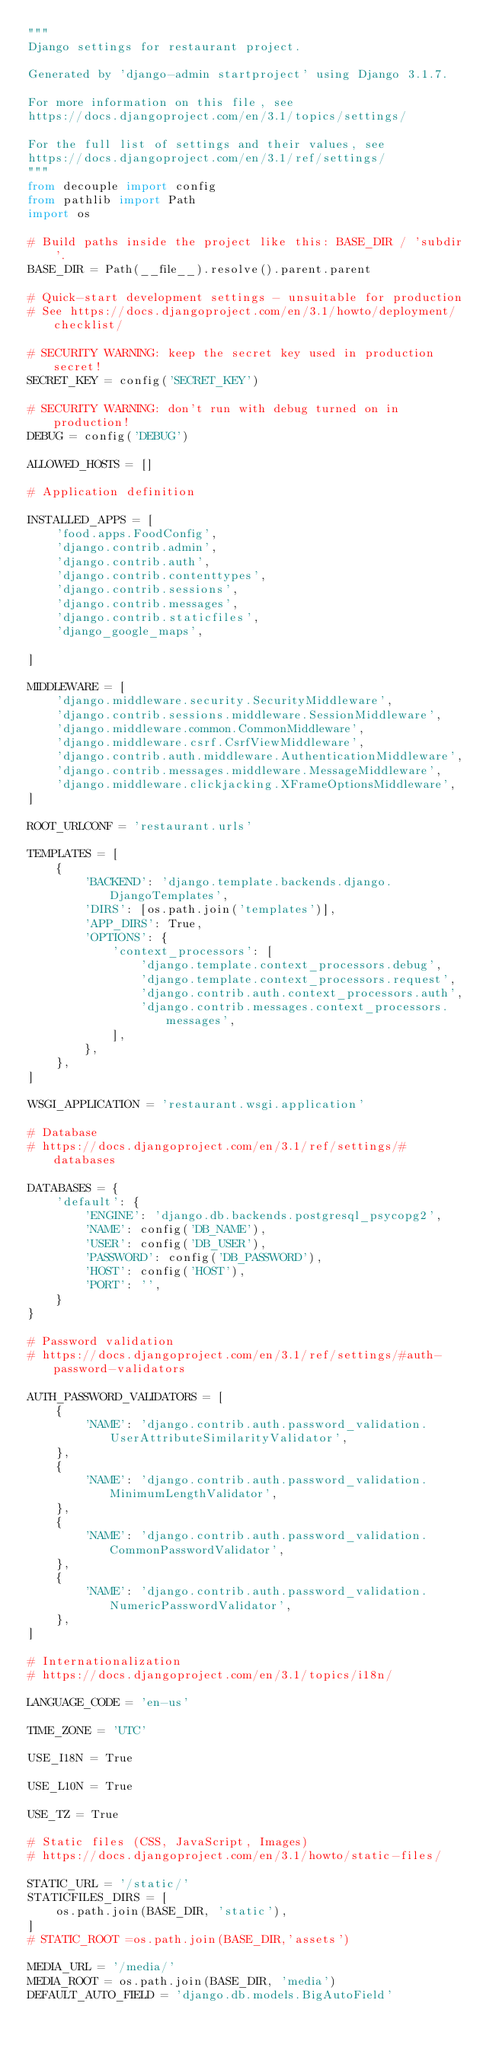Convert code to text. <code><loc_0><loc_0><loc_500><loc_500><_Python_>"""
Django settings for restaurant project.

Generated by 'django-admin startproject' using Django 3.1.7.

For more information on this file, see
https://docs.djangoproject.com/en/3.1/topics/settings/

For the full list of settings and their values, see
https://docs.djangoproject.com/en/3.1/ref/settings/
"""
from decouple import config
from pathlib import Path
import os

# Build paths inside the project like this: BASE_DIR / 'subdir'.
BASE_DIR = Path(__file__).resolve().parent.parent

# Quick-start development settings - unsuitable for production
# See https://docs.djangoproject.com/en/3.1/howto/deployment/checklist/

# SECURITY WARNING: keep the secret key used in production secret!
SECRET_KEY = config('SECRET_KEY')

# SECURITY WARNING: don't run with debug turned on in production!
DEBUG = config('DEBUG')

ALLOWED_HOSTS = []

# Application definition

INSTALLED_APPS = [
    'food.apps.FoodConfig',
    'django.contrib.admin',
    'django.contrib.auth',
    'django.contrib.contenttypes',
    'django.contrib.sessions',
    'django.contrib.messages',
    'django.contrib.staticfiles',
    'django_google_maps',

]

MIDDLEWARE = [
    'django.middleware.security.SecurityMiddleware',
    'django.contrib.sessions.middleware.SessionMiddleware',
    'django.middleware.common.CommonMiddleware',
    'django.middleware.csrf.CsrfViewMiddleware',
    'django.contrib.auth.middleware.AuthenticationMiddleware',
    'django.contrib.messages.middleware.MessageMiddleware',
    'django.middleware.clickjacking.XFrameOptionsMiddleware',
]

ROOT_URLCONF = 'restaurant.urls'

TEMPLATES = [
    {
        'BACKEND': 'django.template.backends.django.DjangoTemplates',
        'DIRS': [os.path.join('templates')],
        'APP_DIRS': True,
        'OPTIONS': {
            'context_processors': [
                'django.template.context_processors.debug',
                'django.template.context_processors.request',
                'django.contrib.auth.context_processors.auth',
                'django.contrib.messages.context_processors.messages',
            ],
        },
    },
]

WSGI_APPLICATION = 'restaurant.wsgi.application'

# Database
# https://docs.djangoproject.com/en/3.1/ref/settings/#databases

DATABASES = {
    'default': {
        'ENGINE': 'django.db.backends.postgresql_psycopg2',
        'NAME': config('DB_NAME'),
        'USER': config('DB_USER'),
        'PASSWORD': config('DB_PASSWORD'),
        'HOST': config('HOST'),
        'PORT': '',
    }
}

# Password validation
# https://docs.djangoproject.com/en/3.1/ref/settings/#auth-password-validators

AUTH_PASSWORD_VALIDATORS = [
    {
        'NAME': 'django.contrib.auth.password_validation.UserAttributeSimilarityValidator',
    },
    {
        'NAME': 'django.contrib.auth.password_validation.MinimumLengthValidator',
    },
    {
        'NAME': 'django.contrib.auth.password_validation.CommonPasswordValidator',
    },
    {
        'NAME': 'django.contrib.auth.password_validation.NumericPasswordValidator',
    },
]

# Internationalization
# https://docs.djangoproject.com/en/3.1/topics/i18n/

LANGUAGE_CODE = 'en-us'

TIME_ZONE = 'UTC'

USE_I18N = True

USE_L10N = True

USE_TZ = True

# Static files (CSS, JavaScript, Images)
# https://docs.djangoproject.com/en/3.1/howto/static-files/

STATIC_URL = '/static/'
STATICFILES_DIRS = [
    os.path.join(BASE_DIR, 'static'),
]
# STATIC_ROOT =os.path.join(BASE_DIR,'assets')

MEDIA_URL = '/media/'
MEDIA_ROOT = os.path.join(BASE_DIR, 'media')
DEFAULT_AUTO_FIELD = 'django.db.models.BigAutoField'
</code> 